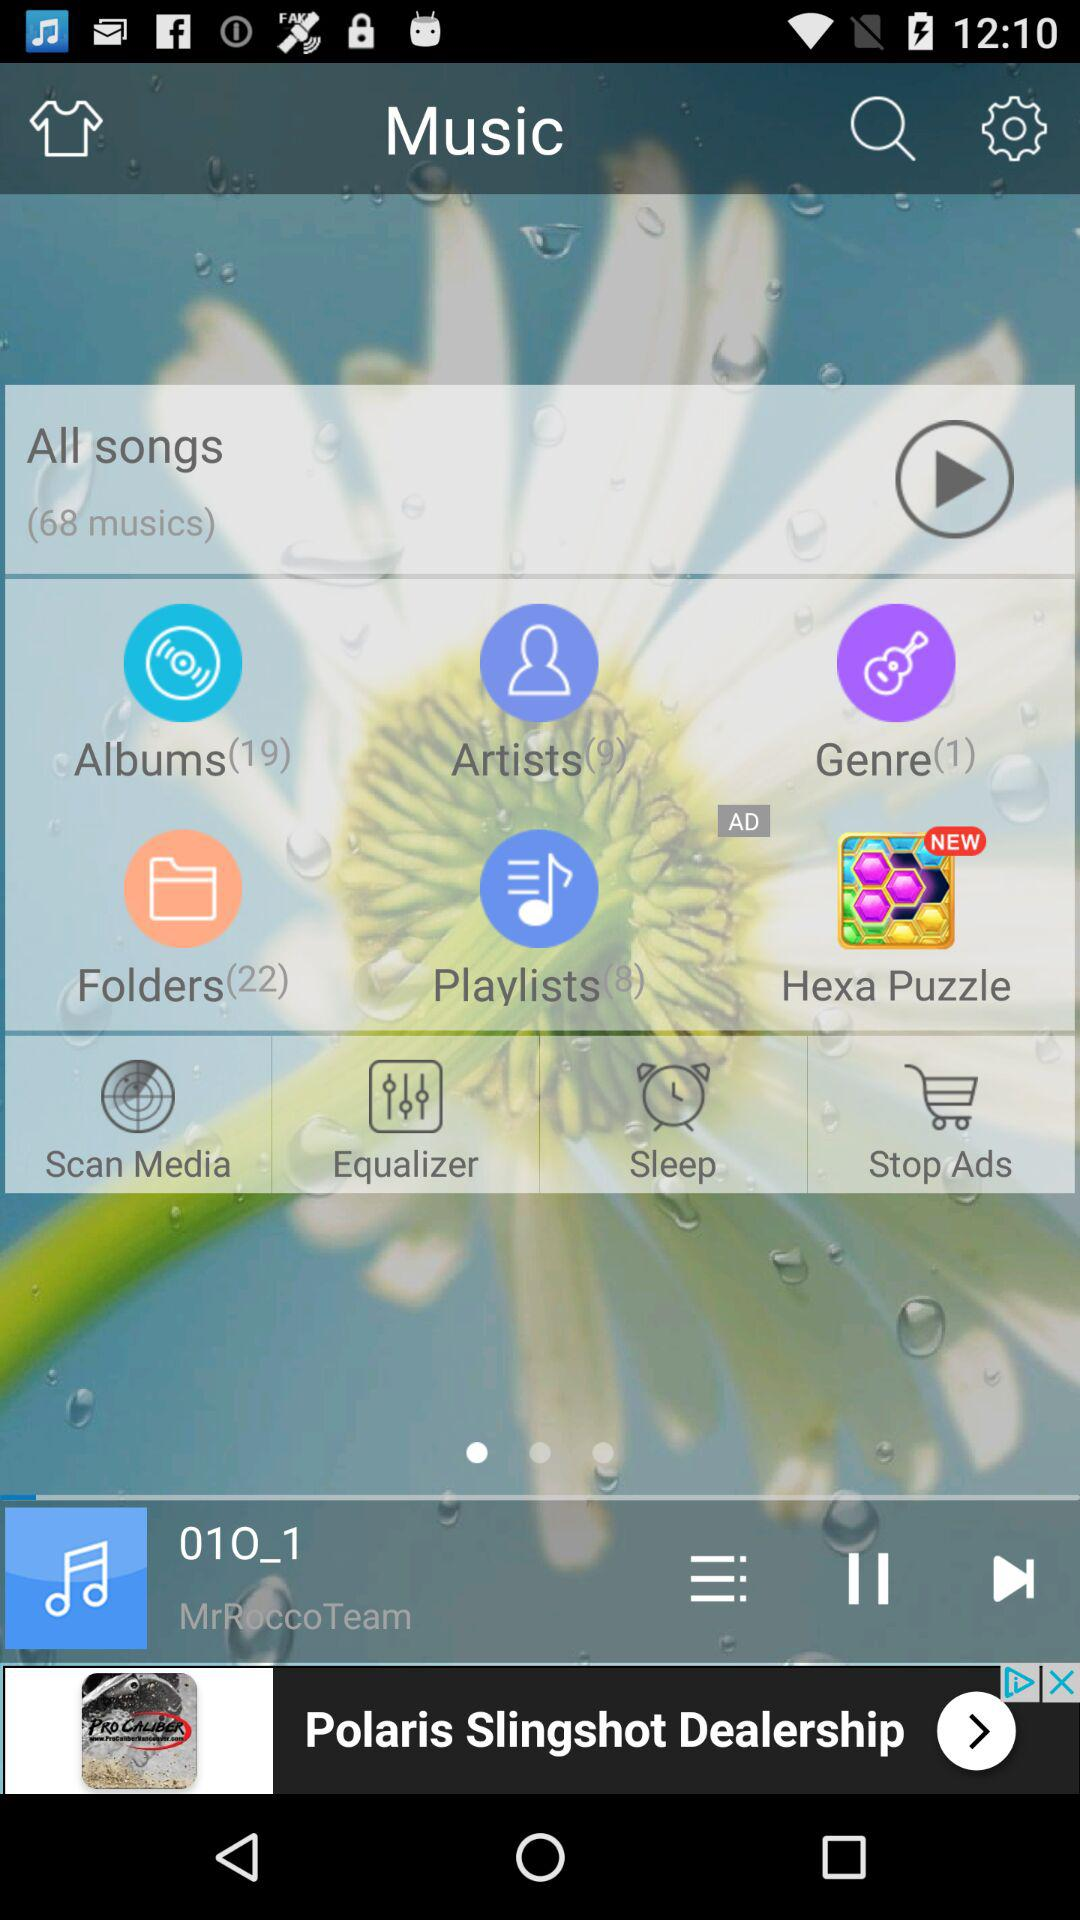How many musics are present in "All songs"? There are 68 musics present in "All songs". 